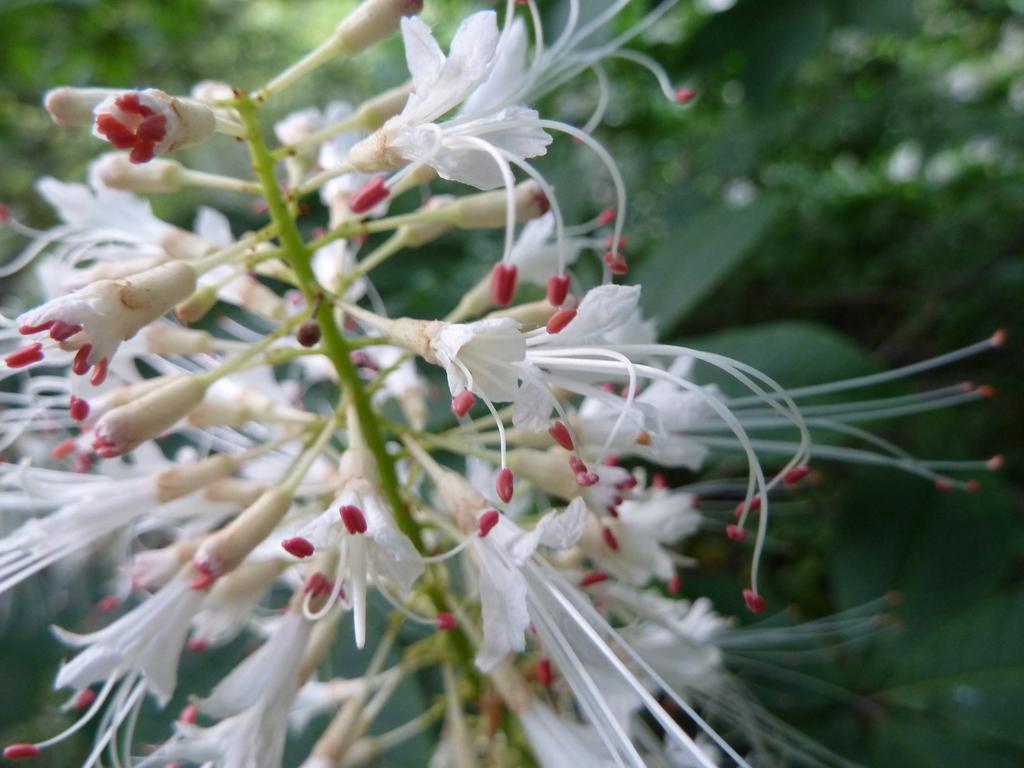In one or two sentences, can you explain what this image depicts? There is a white grevillea and the background is blurred. 